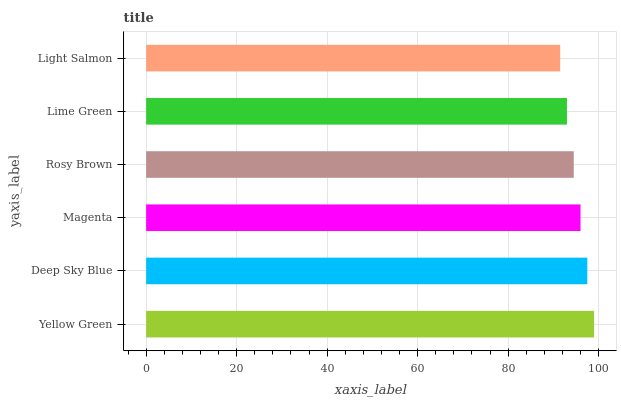Is Light Salmon the minimum?
Answer yes or no. Yes. Is Yellow Green the maximum?
Answer yes or no. Yes. Is Deep Sky Blue the minimum?
Answer yes or no. No. Is Deep Sky Blue the maximum?
Answer yes or no. No. Is Yellow Green greater than Deep Sky Blue?
Answer yes or no. Yes. Is Deep Sky Blue less than Yellow Green?
Answer yes or no. Yes. Is Deep Sky Blue greater than Yellow Green?
Answer yes or no. No. Is Yellow Green less than Deep Sky Blue?
Answer yes or no. No. Is Magenta the high median?
Answer yes or no. Yes. Is Rosy Brown the low median?
Answer yes or no. Yes. Is Yellow Green the high median?
Answer yes or no. No. Is Lime Green the low median?
Answer yes or no. No. 